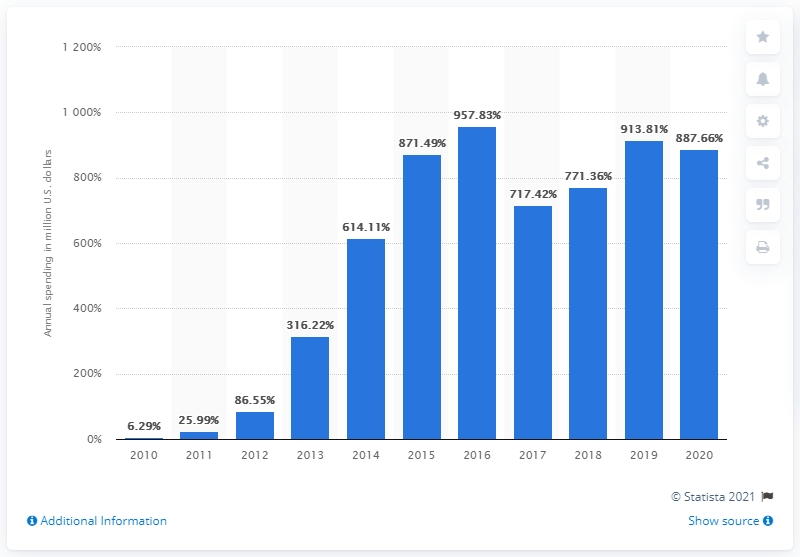List a handful of essential elements in this visual. Twitter spent $887.66 on sales and marketing in the last year. 